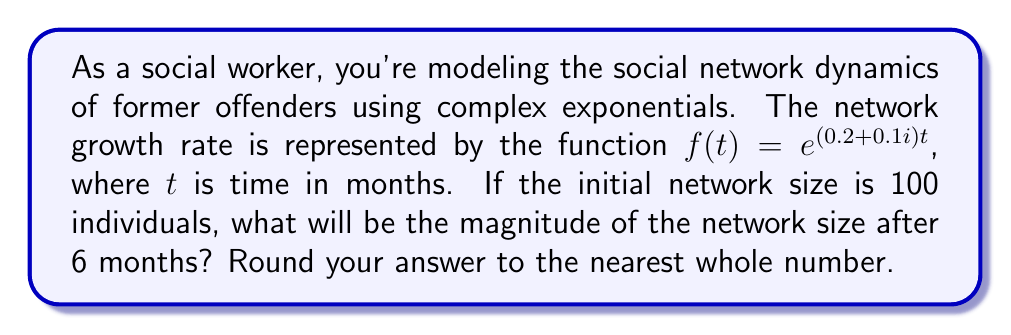Provide a solution to this math problem. To solve this problem, we'll follow these steps:

1) The general form of the network size function is:
   $$N(t) = N_0 \cdot e^{(a+bi)t}$$
   where $N_0$ is the initial network size, $a$ is the real growth rate, and $b$ is the imaginary growth rate.

2) In this case:
   $N_0 = 100$
   $a = 0.2$
   $b = 0.1$
   $t = 6$

3) Substituting these values:
   $$N(6) = 100 \cdot e^{(0.2+0.1i)6}$$

4) To find the magnitude, we use the property of complex exponentials:
   $$|e^{(a+bi)t}| = e^{at}$$

5) Therefore, the magnitude of the network size after 6 months is:
   $$|N(6)| = 100 \cdot e^{0.2 \cdot 6} = 100 \cdot e^{1.2}$$

6) Calculate:
   $$100 \cdot e^{1.2} \approx 332.01$$

7) Rounding to the nearest whole number:
   $$|N(6)| \approx 332$$
Answer: 332 